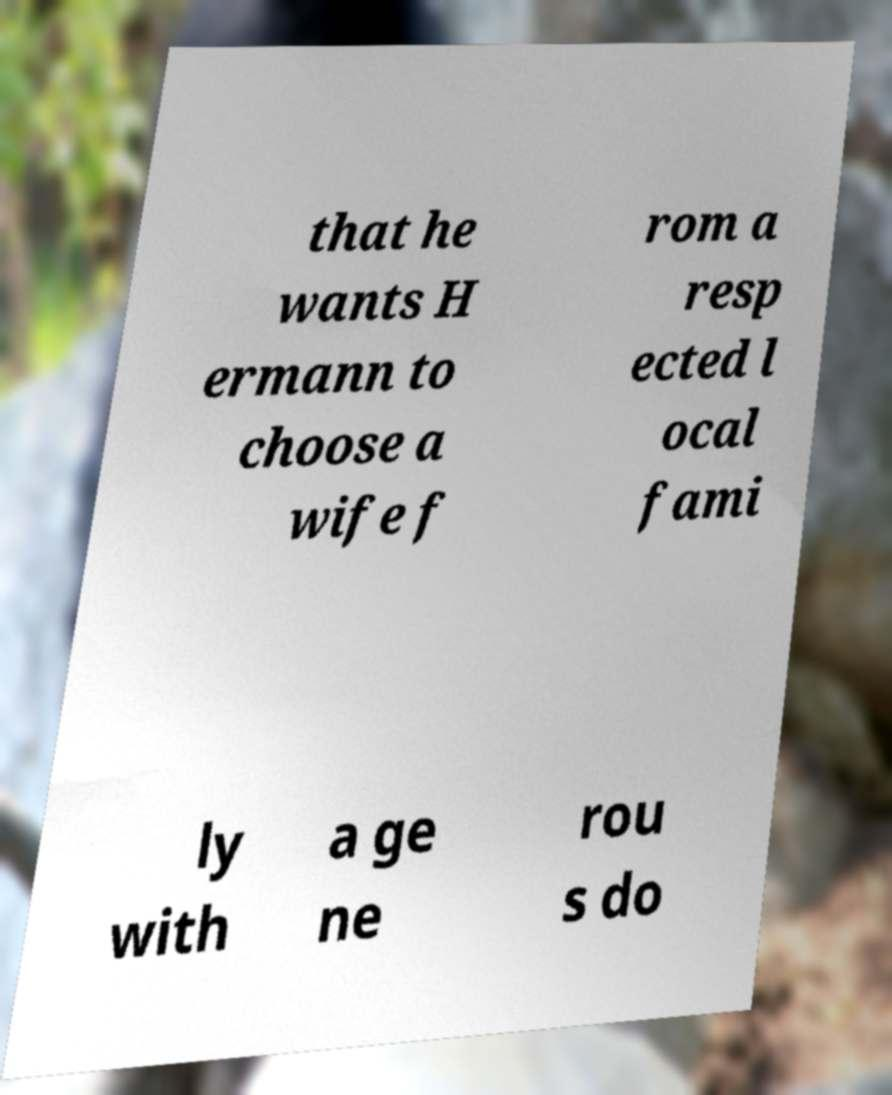Can you accurately transcribe the text from the provided image for me? that he wants H ermann to choose a wife f rom a resp ected l ocal fami ly with a ge ne rou s do 